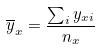<formula> <loc_0><loc_0><loc_500><loc_500>\overline { y } _ { x } = \frac { \sum _ { i } y _ { x i } } { n _ { x } }</formula> 